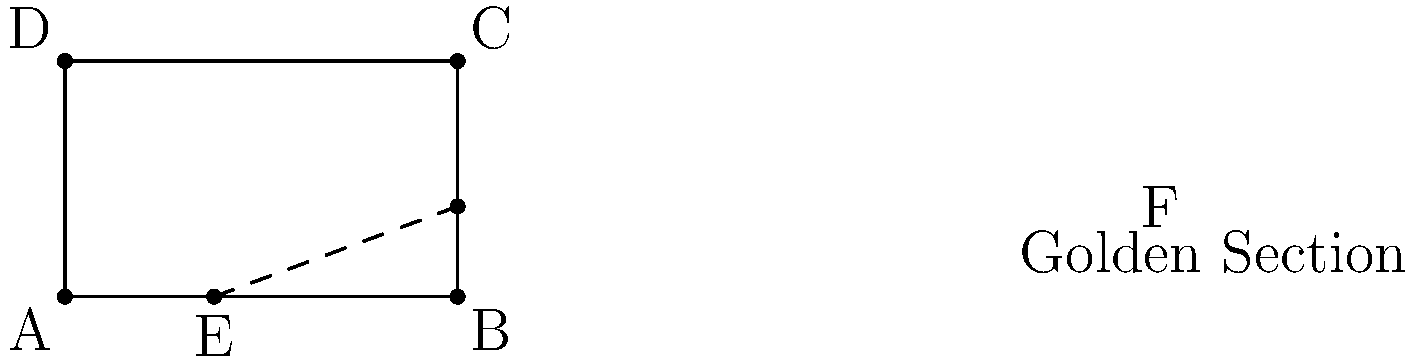In your village landscape painting, you've divided the canvas using the golden ratio. If the width of the canvas is 100 cm, what is the length of the shorter segment (AE) created by this division, rounded to the nearest centimeter? To find the length of the shorter segment created by the golden ratio, we need to follow these steps:

1) The golden ratio is approximately equal to 1.618033988749895, often denoted by the Greek letter $\phi$ (phi).

2) In a golden ratio division, the ratio of the whole to the larger part is equal to the ratio of the larger part to the smaller part.

3) Let $x$ be the length of the shorter segment (AE). Then, the length of the longer segment (EB) is $100 - x$.

4) We can set up the following equation:
   
   $\frac{100}{100-x} = \frac{100-x}{x} = \phi$

5) This can be simplified to:
   
   $\frac{100}{x} = \phi + 1 \approx 2.618033988749895$

6) Solving for $x$:
   
   $x = \frac{100}{2.618033988749895} \approx 38.19660112501051$

7) Rounding to the nearest centimeter:
   
   $x \approx 38$ cm

Therefore, the length of the shorter segment (AE) is approximately 38 cm.
Answer: 38 cm 